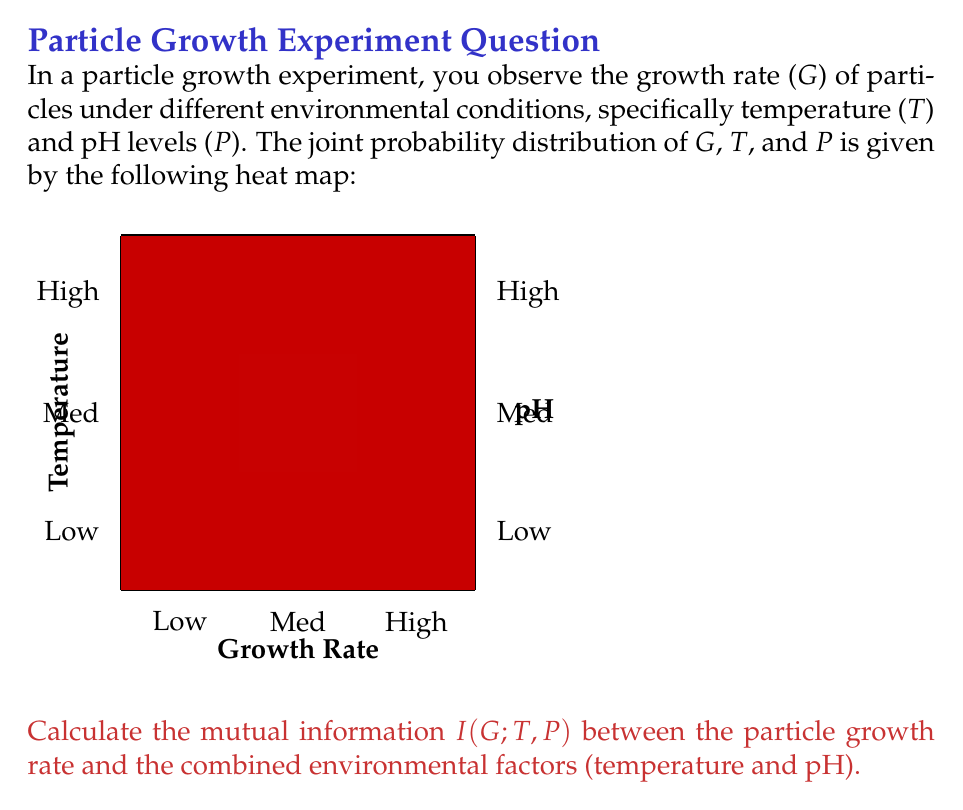What is the answer to this math problem? To calculate the mutual information $I(G;T,P)$, we'll follow these steps:

1) First, we need to calculate the marginal probabilities:

   $P(G=\text{Low}) = 0.05 + 0.10 + 0.05 = 0.20$
   $P(G=\text{Med}) = 0.10 + 0.30 + 0.10 = 0.50$
   $P(G=\text{High}) = 0.05 + 0.20 + 0.05 = 0.30$

   $P(T=\text{Low}, P=\text{Low}) = 0.05$
   $P(T=\text{Low}, P=\text{Med}) = 0.10$
   $P(T=\text{Low}, P=\text{High}) = 0.05$
   $P(T=\text{Med}, P=\text{Low}) = 0.10$
   $P(T=\text{Med}, P=\text{Med}) = 0.30$
   $P(T=\text{Med}, P=\text{High}) = 0.10$
   $P(T=\text{High}, P=\text{Low}) = 0.05$
   $P(T=\text{High}, P=\text{Med}) = 0.20$
   $P(T=\text{High}, P=\text{High}) = 0.05$

2) The mutual information is defined as:

   $$I(G;T,P) = \sum_{g,t,p} P(g,t,p) \log_2 \frac{P(g,t,p)}{P(g)P(t,p)}$$

3) Let's calculate each term:

   $0.05 \log_2 \frac{0.05}{0.20 \cdot 0.05} = 0.05 \log_2 5 = 0.1161$
   $0.10 \log_2 \frac{0.10}{0.50 \cdot 0.10} = 0.10 \log_2 2 = 0.1000$
   $0.05 \log_2 \frac{0.05}{0.30 \cdot 0.05} = 0.05 \log_2 \frac{10}{3} = 0.0874$
   $0.10 \log_2 \frac{0.10}{0.20 \cdot 0.10} = 0.10 \log_2 5 = 0.2322$
   $0.30 \log_2 \frac{0.30}{0.50 \cdot 0.30} = 0.30 \log_2 2 = 0.3000$
   $0.10 \log_2 \frac{0.10}{0.30 \cdot 0.10} = 0.10 \log_2 \frac{10}{3} = 0.1749$
   $0.05 \log_2 \frac{0.05}{0.20 \cdot 0.05} = 0.05 \log_2 5 = 0.1161$
   $0.20 \log_2 \frac{0.20}{0.50 \cdot 0.20} = 0.20 \log_2 2 = 0.2000$
   $0.05 \log_2 \frac{0.05}{0.30 \cdot 0.05} = 0.05 \log_2 \frac{10}{3} = 0.0874$

4) Sum all these terms:

   $I(G;T,P) = 0.1161 + 0.1000 + 0.0874 + 0.2322 + 0.3000 + 0.1749 + 0.1161 + 0.2000 + 0.0874 = 1.4141$ bits
Answer: 1.4141 bits 